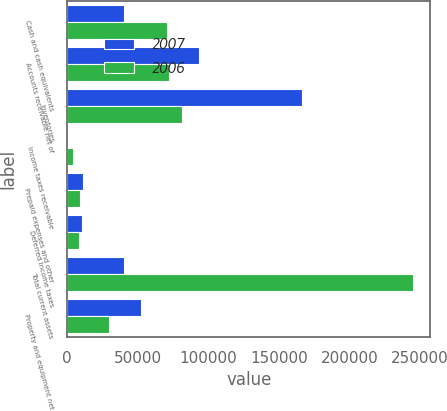Convert chart. <chart><loc_0><loc_0><loc_500><loc_500><stacked_bar_chart><ecel><fcel>Cash and cash equivalents<fcel>Accounts receivable net of<fcel>Inventories<fcel>Income taxes receivable<fcel>Prepaid expenses and other<fcel>Deferred income taxes<fcel>Total current assets<fcel>Property and equipment net<nl><fcel>2007<fcel>40588<fcel>93515<fcel>166082<fcel>614<fcel>11028<fcel>10418<fcel>40588<fcel>52332<nl><fcel>2006<fcel>70655<fcel>71867<fcel>81031<fcel>4310<fcel>8944<fcel>8145<fcel>244952<fcel>29923<nl></chart> 